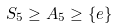<formula> <loc_0><loc_0><loc_500><loc_500>S _ { 5 } \geq A _ { 5 } \geq \{ e \}</formula> 